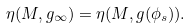<formula> <loc_0><loc_0><loc_500><loc_500>\eta ( M , g _ { \infty } ) = \eta ( M , g ( \phi _ { s } ) ) .</formula> 